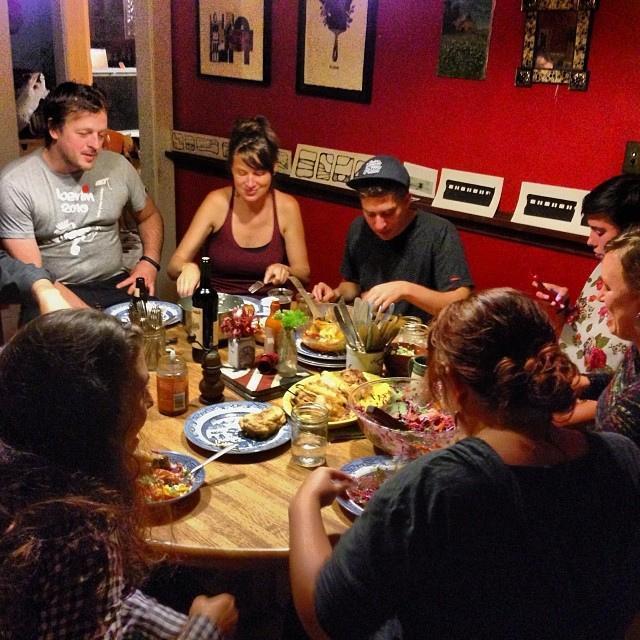How many bottles of wine do they have?
Give a very brief answer. 1. How many people are in the photo?
Give a very brief answer. 8. How many bowls are visible?
Give a very brief answer. 3. 